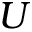<formula> <loc_0><loc_0><loc_500><loc_500>U</formula> 